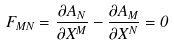<formula> <loc_0><loc_0><loc_500><loc_500>F _ { M N } = \frac { \partial A _ { N } } { \partial X ^ { M } } - \frac { \partial A _ { M } } { \partial X ^ { N } } = 0</formula> 